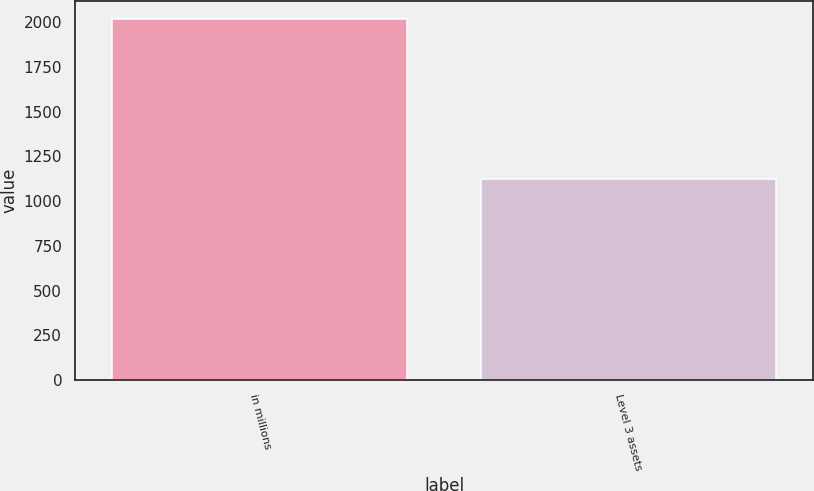<chart> <loc_0><loc_0><loc_500><loc_500><bar_chart><fcel>in millions<fcel>Level 3 assets<nl><fcel>2017<fcel>1126<nl></chart> 